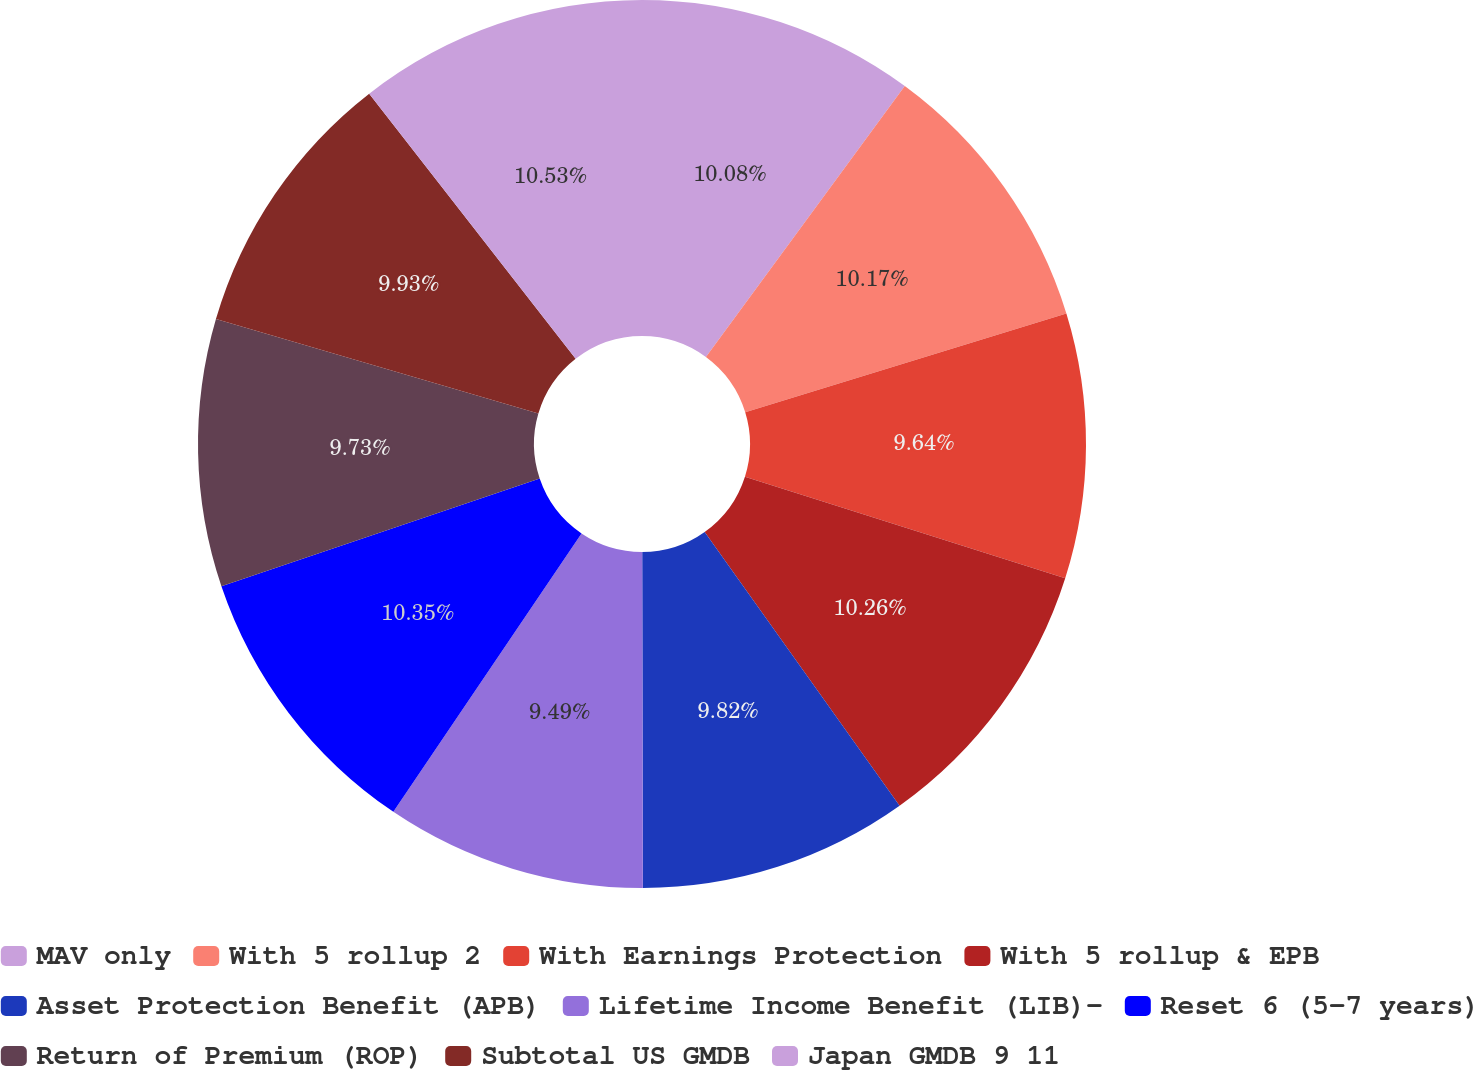Convert chart to OTSL. <chart><loc_0><loc_0><loc_500><loc_500><pie_chart><fcel>MAV only<fcel>With 5 rollup 2<fcel>With Earnings Protection<fcel>With 5 rollup & EPB<fcel>Asset Protection Benefit (APB)<fcel>Lifetime Income Benefit (LIB)-<fcel>Reset 6 (5-7 years)<fcel>Return of Premium (ROP)<fcel>Subtotal US GMDB<fcel>Japan GMDB 9 11<nl><fcel>10.08%<fcel>10.17%<fcel>9.64%<fcel>10.26%<fcel>9.82%<fcel>9.49%<fcel>10.35%<fcel>9.73%<fcel>9.93%<fcel>10.53%<nl></chart> 